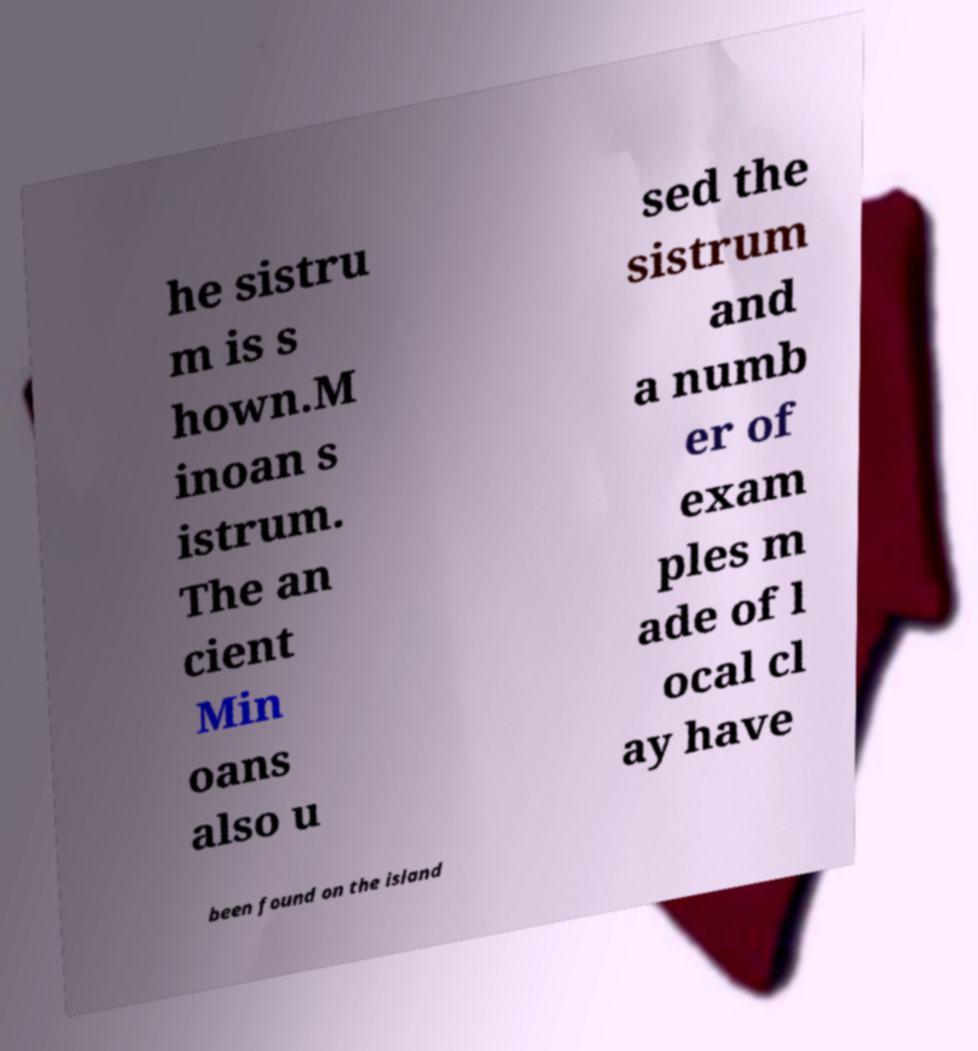Could you assist in decoding the text presented in this image and type it out clearly? he sistru m is s hown.M inoan s istrum. The an cient Min oans also u sed the sistrum and a numb er of exam ples m ade of l ocal cl ay have been found on the island 